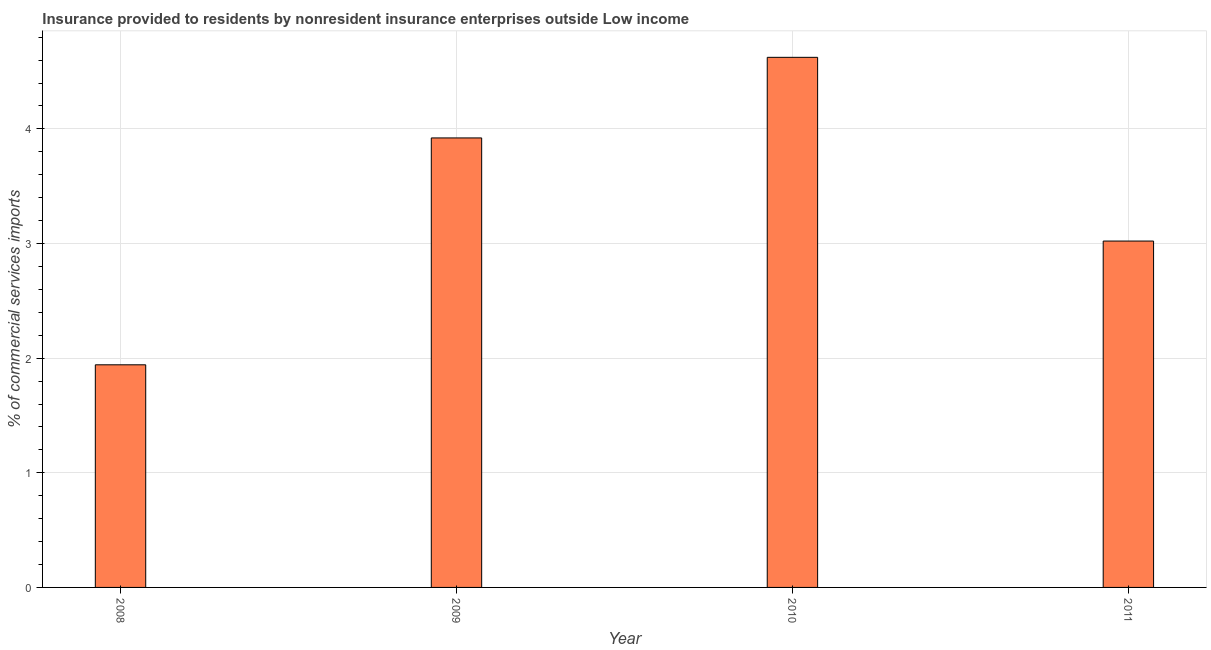Does the graph contain any zero values?
Your answer should be very brief. No. What is the title of the graph?
Your answer should be very brief. Insurance provided to residents by nonresident insurance enterprises outside Low income. What is the label or title of the X-axis?
Offer a very short reply. Year. What is the label or title of the Y-axis?
Your answer should be very brief. % of commercial services imports. What is the insurance provided by non-residents in 2008?
Keep it short and to the point. 1.94. Across all years, what is the maximum insurance provided by non-residents?
Your answer should be compact. 4.62. Across all years, what is the minimum insurance provided by non-residents?
Offer a terse response. 1.94. In which year was the insurance provided by non-residents minimum?
Provide a succinct answer. 2008. What is the sum of the insurance provided by non-residents?
Your answer should be compact. 13.51. What is the average insurance provided by non-residents per year?
Give a very brief answer. 3.38. What is the median insurance provided by non-residents?
Your response must be concise. 3.47. Do a majority of the years between 2008 and 2011 (inclusive) have insurance provided by non-residents greater than 2.4 %?
Make the answer very short. Yes. What is the ratio of the insurance provided by non-residents in 2008 to that in 2010?
Ensure brevity in your answer.  0.42. Is the insurance provided by non-residents in 2009 less than that in 2011?
Make the answer very short. No. Is the difference between the insurance provided by non-residents in 2008 and 2009 greater than the difference between any two years?
Give a very brief answer. No. What is the difference between the highest and the second highest insurance provided by non-residents?
Your response must be concise. 0.7. What is the difference between the highest and the lowest insurance provided by non-residents?
Your answer should be compact. 2.68. In how many years, is the insurance provided by non-residents greater than the average insurance provided by non-residents taken over all years?
Provide a succinct answer. 2. Are all the bars in the graph horizontal?
Provide a short and direct response. No. Are the values on the major ticks of Y-axis written in scientific E-notation?
Keep it short and to the point. No. What is the % of commercial services imports of 2008?
Provide a succinct answer. 1.94. What is the % of commercial services imports in 2009?
Make the answer very short. 3.92. What is the % of commercial services imports in 2010?
Provide a short and direct response. 4.62. What is the % of commercial services imports of 2011?
Your answer should be compact. 3.02. What is the difference between the % of commercial services imports in 2008 and 2009?
Give a very brief answer. -1.98. What is the difference between the % of commercial services imports in 2008 and 2010?
Keep it short and to the point. -2.68. What is the difference between the % of commercial services imports in 2008 and 2011?
Offer a terse response. -1.08. What is the difference between the % of commercial services imports in 2009 and 2010?
Your answer should be compact. -0.7. What is the difference between the % of commercial services imports in 2009 and 2011?
Offer a very short reply. 0.9. What is the difference between the % of commercial services imports in 2010 and 2011?
Ensure brevity in your answer.  1.6. What is the ratio of the % of commercial services imports in 2008 to that in 2009?
Offer a very short reply. 0.49. What is the ratio of the % of commercial services imports in 2008 to that in 2010?
Offer a very short reply. 0.42. What is the ratio of the % of commercial services imports in 2008 to that in 2011?
Give a very brief answer. 0.64. What is the ratio of the % of commercial services imports in 2009 to that in 2010?
Your answer should be very brief. 0.85. What is the ratio of the % of commercial services imports in 2009 to that in 2011?
Provide a succinct answer. 1.3. What is the ratio of the % of commercial services imports in 2010 to that in 2011?
Make the answer very short. 1.53. 